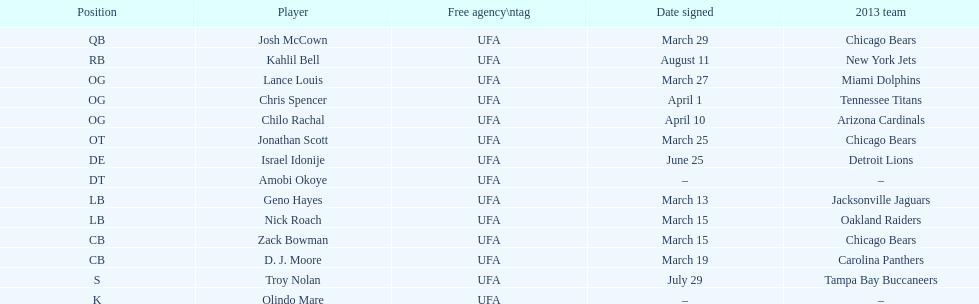Before troy nolan, who was the last player to be signed? Israel Idonije. 